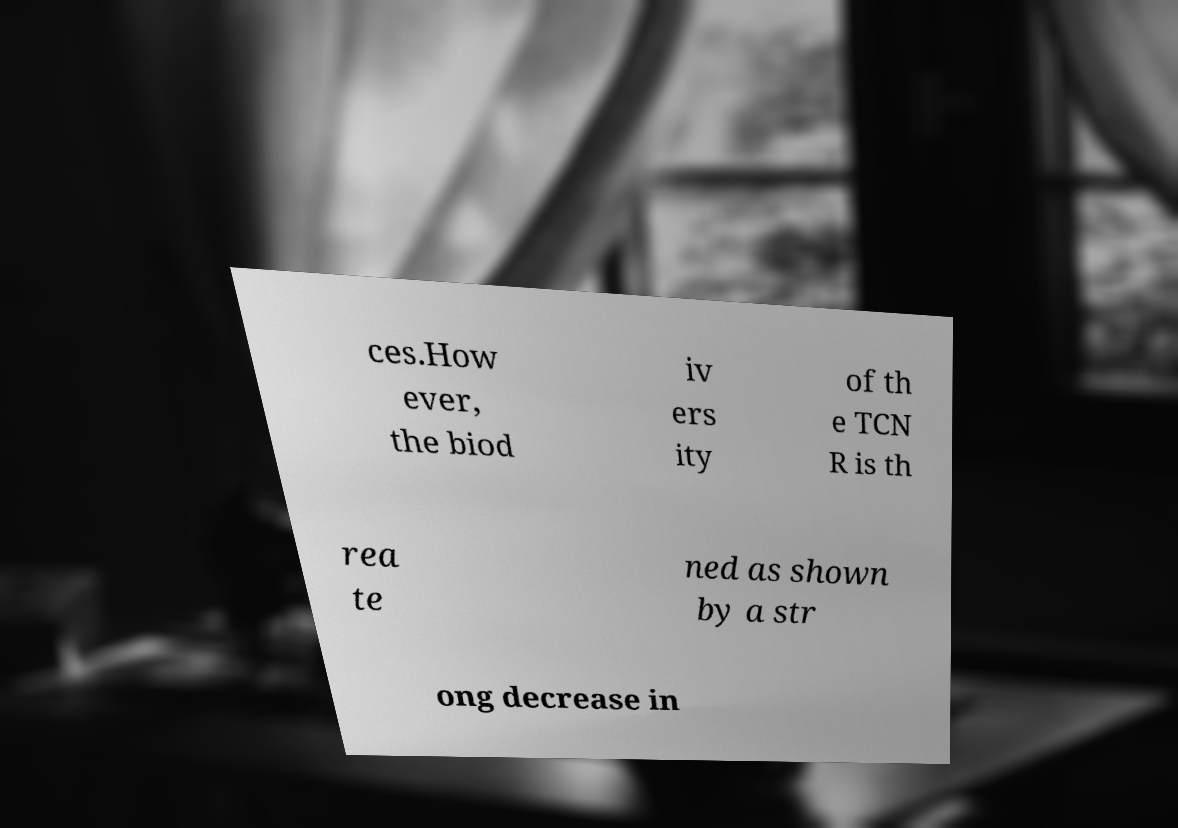Could you assist in decoding the text presented in this image and type it out clearly? ces.How ever, the biod iv ers ity of th e TCN R is th rea te ned as shown by a str ong decrease in 